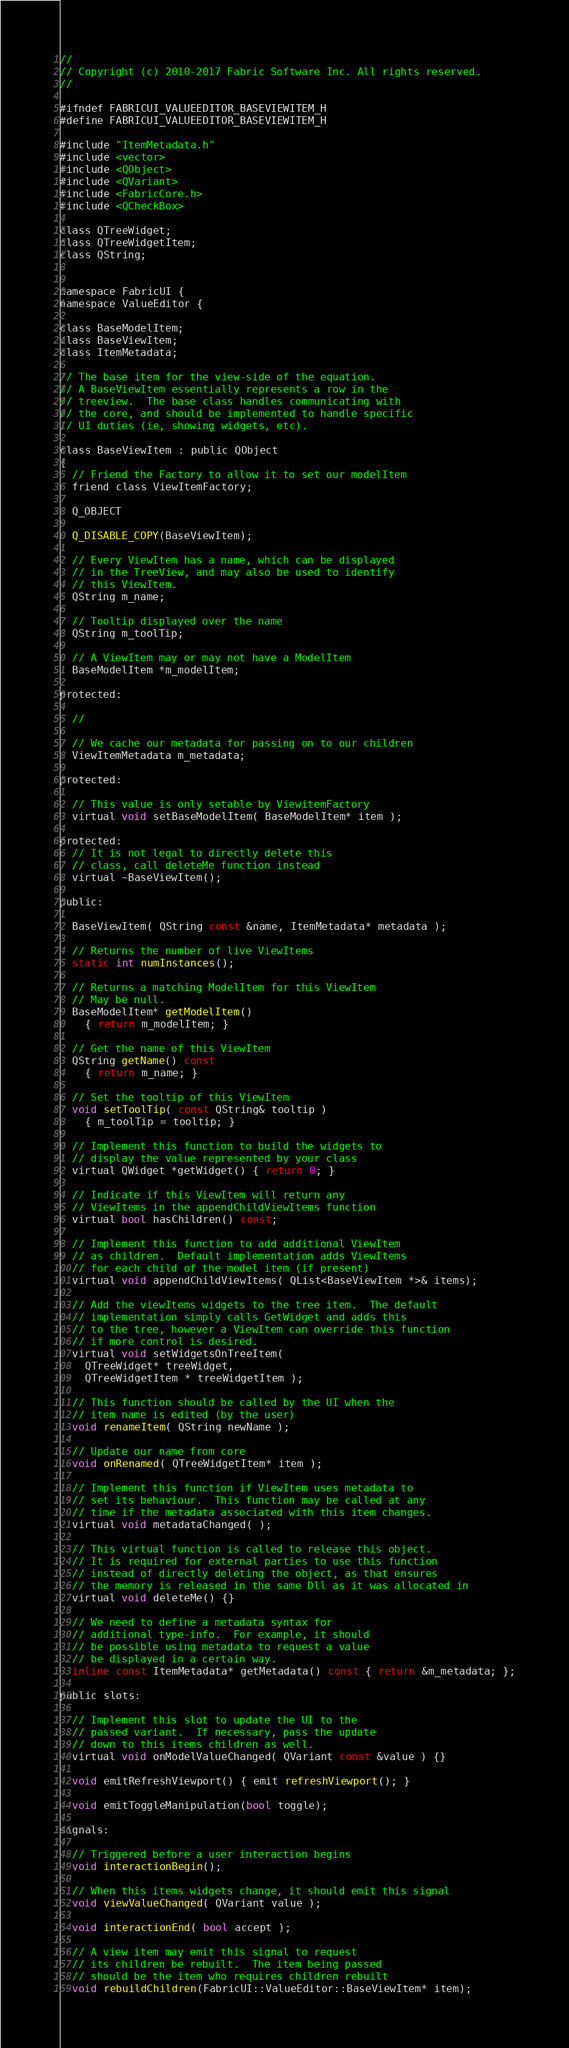<code> <loc_0><loc_0><loc_500><loc_500><_C_>//
// Copyright (c) 2010-2017 Fabric Software Inc. All rights reserved.
//

#ifndef FABRICUI_VALUEEDITOR_BASEVIEWITEM_H
#define FABRICUI_VALUEEDITOR_BASEVIEWITEM_H

#include "ItemMetadata.h"
#include <vector>
#include <QObject>
#include <QVariant>
#include <FabricCore.h>
#include <QCheckBox>

class QTreeWidget;
class QTreeWidgetItem;
class QString;


namespace FabricUI {
namespace ValueEditor {
  
class BaseModelItem;
class BaseViewItem;
class ItemMetadata;

// The base item for the view-side of the equation.
// A BaseViewItem essentially represents a row in the
// treeview.  The base class handles communicating with
// the core, and should be implemented to handle specific
// UI duties (ie, showing widgets, etc).  

class BaseViewItem : public QObject
{
  // Friend the Factory to allow it to set our modelItem
  friend class ViewItemFactory;

  Q_OBJECT

  Q_DISABLE_COPY(BaseViewItem);
  
  // Every ViewItem has a name, which can be displayed 
  // in the TreeView, and may also be used to identify
  // this ViewItem.
  QString m_name;

  // Tooltip displayed over the name
  QString m_toolTip;

  // A ViewItem may or may not have a ModelItem
  BaseModelItem *m_modelItem;

protected:

  // 

  // We cache our metadata for passing on to our children
  ViewItemMetadata m_metadata;

protected:

  // This value is only setable by ViewitemFactory
  virtual void setBaseModelItem( BaseModelItem* item );

protected:
  // It is not legal to directly delete this
  // class, call deleteMe function instead
  virtual ~BaseViewItem();

public:

  BaseViewItem( QString const &name, ItemMetadata* metadata );

  // Returns the number of live ViewItems
  static int numInstances();

  // Returns a matching ModelItem for this ViewItem
  // May be null.
  BaseModelItem* getModelItem()
    { return m_modelItem; }

  // Get the name of this ViewItem
  QString getName() const
    { return m_name; }

  // Set the tooltip of this ViewItem
  void setToolTip( const QString& tooltip )
    { m_toolTip = tooltip; }

  // Implement this function to build the widgets to
  // display the value represented by your class
  virtual QWidget *getWidget() { return 0; }

  // Indicate if this ViewItem will return any 
  // ViewItems in the appendChildViewItems function
  virtual bool hasChildren() const;
  
  // Implement this function to add additional ViewItem
  // as children.  Default implementation adds ViewItems
  // for each child of the model item (if present)
  virtual void appendChildViewItems( QList<BaseViewItem *>& items);

  // Add the viewItems widgets to the tree item.  The default
  // implementation simply calls GetWidget and adds this
  // to the tree, however a ViewItem can override this function 
  // if more control is desired.
  virtual void setWidgetsOnTreeItem(
    QTreeWidget* treeWidget,
    QTreeWidgetItem * treeWidgetItem );

  // This function should be called by the UI when the
  // item name is edited (by the user)
  void renameItem( QString newName );

  // Update our name from core 
  void onRenamed( QTreeWidgetItem* item );

  // Implement this function if ViewItem uses metadata to
  // set its behaviour.  This function may be called at any
  // time if the metadata associated with this item changes.
  virtual void metadataChanged( );

  // This virtual function is called to release this object.
  // It is required for external parties to use this function
  // instead of directly deleting the object, as that ensures
  // the memory is released in the same Dll as it was allocated in
  virtual void deleteMe() {}

  // We need to define a metadata syntax for 
  // additional type-info.  For example, it should
  // be possible using metadata to request a value
  // be displayed in a certain way.
  inline const ItemMetadata* getMetadata() const { return &m_metadata; };

public slots:

  // Implement this slot to update the UI to the
  // passed variant.  If necessary, pass the update
  // down to this items children as well.
  virtual void onModelValueChanged( QVariant const &value ) {}
    
  void emitRefreshViewport() { emit refreshViewport(); }
  
  void emitToggleManipulation(bool toggle);

signals:

  // Triggered before a user interaction begins
  void interactionBegin();

  // When this items widgets change, it should emit this signal
  void viewValueChanged( QVariant value );

  void interactionEnd( bool accept );

  // A view item may emit this signal to request 
  // its children be rebuilt.  The item being passed
  // should be the item who requires children rebuilt
  void rebuildChildren(FabricUI::ValueEditor::BaseViewItem* item);
</code> 